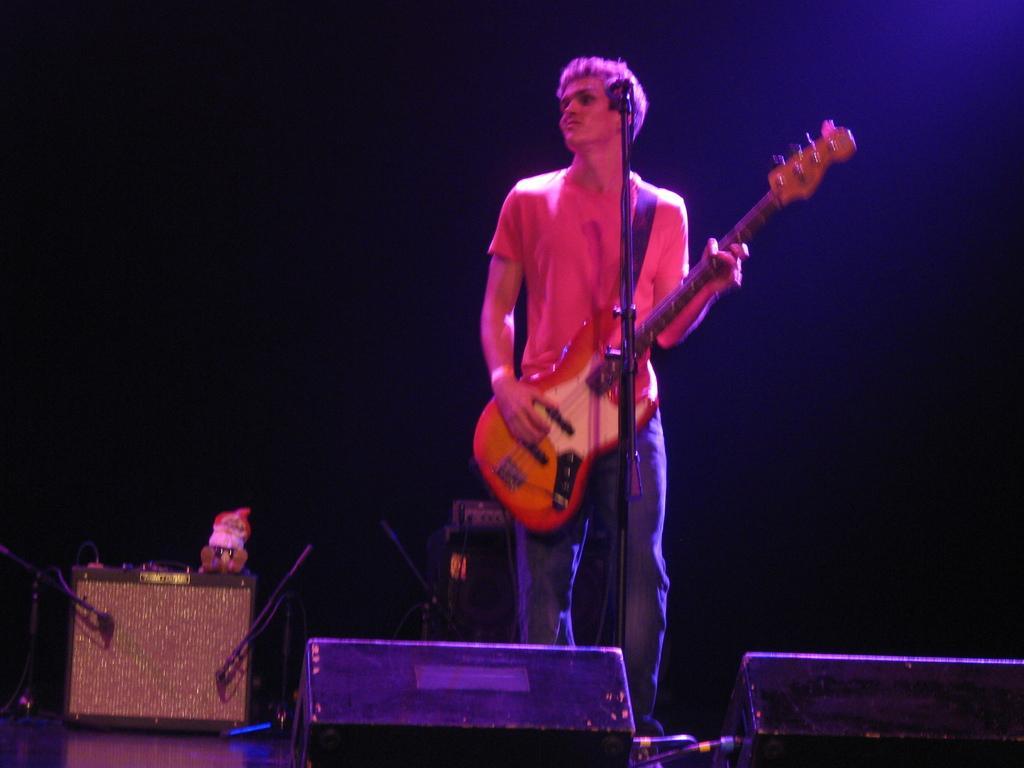In one or two sentences, can you explain what this image depicts? In the middle of the image, there is a person standing and holding a guitar in front of the mike. At the bottom, there are two speakers kept. In the left there is a table on which toy is kept. The background is dark in color. On the top a light is visible. This picture is taken inside a stage. 